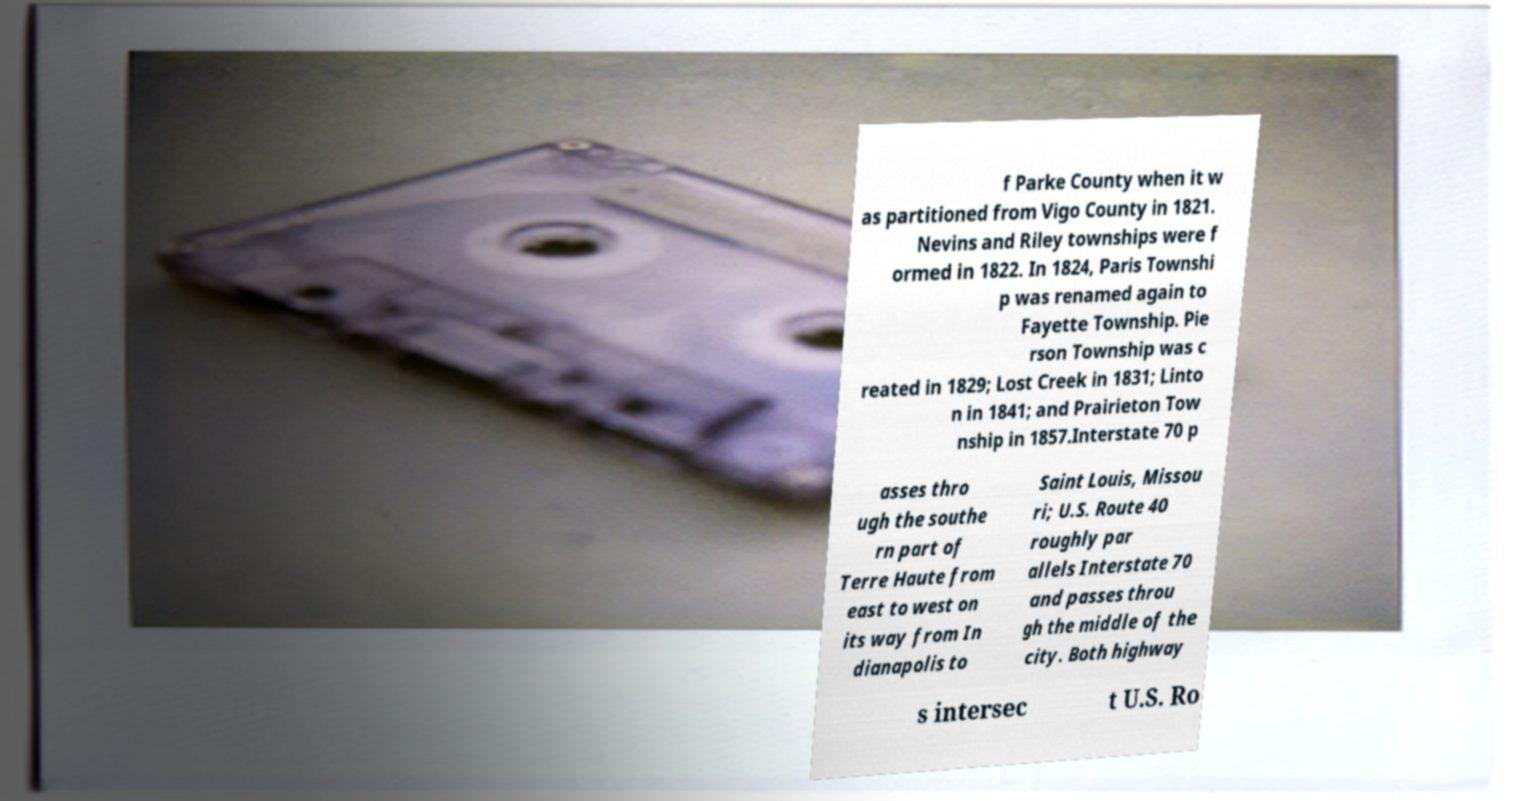Can you read and provide the text displayed in the image?This photo seems to have some interesting text. Can you extract and type it out for me? f Parke County when it w as partitioned from Vigo County in 1821. Nevins and Riley townships were f ormed in 1822. In 1824, Paris Townshi p was renamed again to Fayette Township. Pie rson Township was c reated in 1829; Lost Creek in 1831; Linto n in 1841; and Prairieton Tow nship in 1857.Interstate 70 p asses thro ugh the southe rn part of Terre Haute from east to west on its way from In dianapolis to Saint Louis, Missou ri; U.S. Route 40 roughly par allels Interstate 70 and passes throu gh the middle of the city. Both highway s intersec t U.S. Ro 